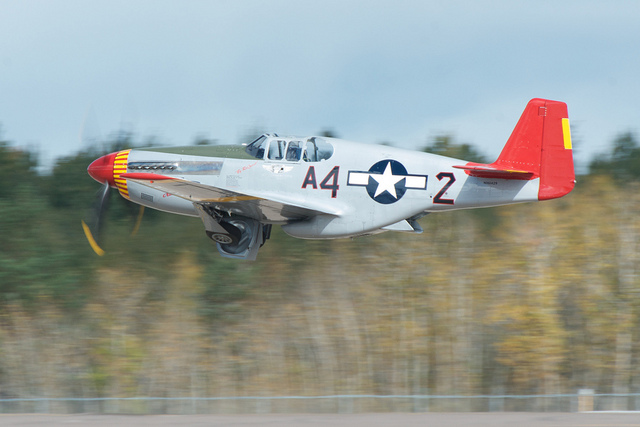Is this a commercial airplane? This is not a commercial airplane; it appears to be a vintage warbird, specifically a P-51 Mustang, which is a military fighter aircraft that was used historically during World War II. 